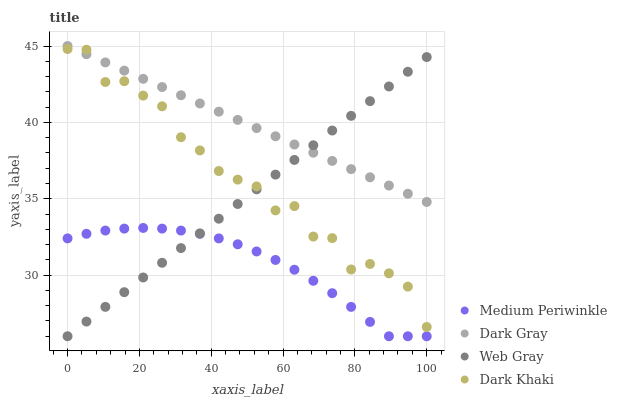Does Medium Periwinkle have the minimum area under the curve?
Answer yes or no. Yes. Does Dark Gray have the maximum area under the curve?
Answer yes or no. Yes. Does Dark Khaki have the minimum area under the curve?
Answer yes or no. No. Does Dark Khaki have the maximum area under the curve?
Answer yes or no. No. Is Dark Gray the smoothest?
Answer yes or no. Yes. Is Dark Khaki the roughest?
Answer yes or no. Yes. Is Web Gray the smoothest?
Answer yes or no. No. Is Web Gray the roughest?
Answer yes or no. No. Does Web Gray have the lowest value?
Answer yes or no. Yes. Does Dark Khaki have the lowest value?
Answer yes or no. No. Does Dark Gray have the highest value?
Answer yes or no. Yes. Does Dark Khaki have the highest value?
Answer yes or no. No. Is Medium Periwinkle less than Dark Gray?
Answer yes or no. Yes. Is Dark Gray greater than Medium Periwinkle?
Answer yes or no. Yes. Does Web Gray intersect Dark Gray?
Answer yes or no. Yes. Is Web Gray less than Dark Gray?
Answer yes or no. No. Is Web Gray greater than Dark Gray?
Answer yes or no. No. Does Medium Periwinkle intersect Dark Gray?
Answer yes or no. No. 